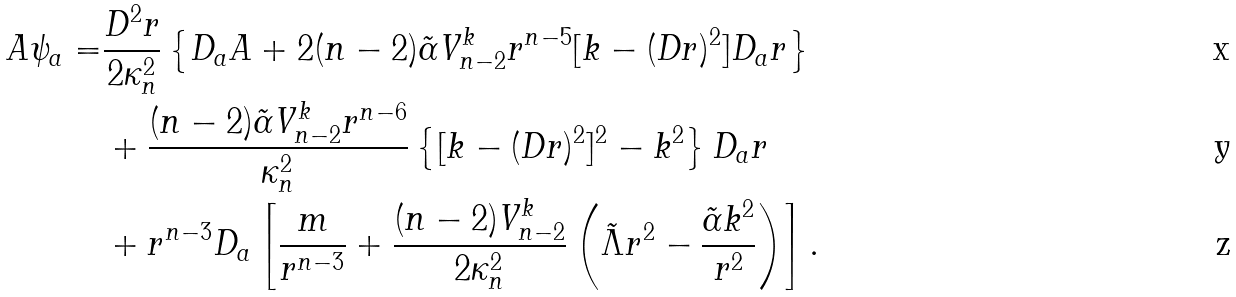<formula> <loc_0><loc_0><loc_500><loc_500>A \psi _ { a } = & \frac { D ^ { 2 } r } { 2 \kappa _ { n } ^ { 2 } } \left \{ D _ { a } A + 2 ( n - 2 ) \tilde { \alpha } V _ { n - 2 } ^ { k } r ^ { n - 5 } [ k - ( D r ) ^ { 2 } ] D _ { a } r \right \} \\ & + \frac { ( n - 2 ) \tilde { \alpha } V _ { n - 2 } ^ { k } r ^ { n - 6 } } { \kappa _ { n } ^ { 2 } } \left \{ [ k - ( D r ) ^ { 2 } ] ^ { 2 } - k ^ { 2 } \right \} D _ { a } r \\ & + r ^ { n - 3 } D _ { a } \left [ \frac { m } { r ^ { n - 3 } } + \frac { ( n - 2 ) V _ { n - 2 } ^ { k } } { 2 \kappa _ { n } ^ { 2 } } \left ( \tilde { \Lambda } r ^ { 2 } - \frac { \tilde { \alpha } k ^ { 2 } } { r ^ { 2 } } \right ) \right ] .</formula> 